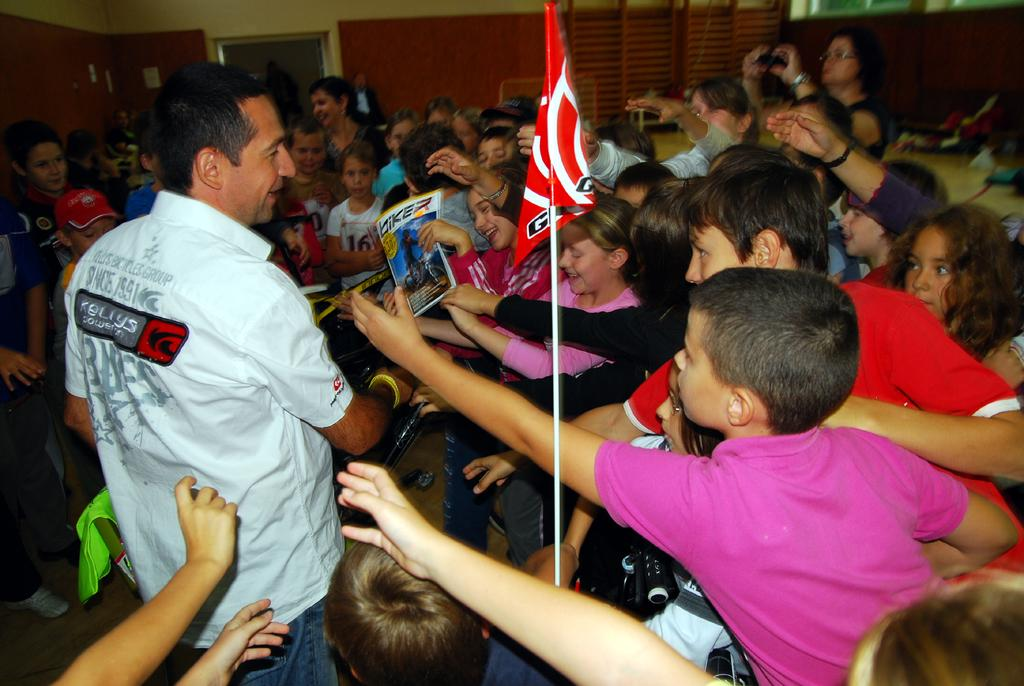What can be seen in the image in terms of people? There are people and children standing in the image. What is the prominent feature in the front of the image? There is a red color flag in the front of the image. How would you describe the quality of the image's background? The image is slightly blurry in the background. What type of linen is used to create the flag in the image? There is no information about the type of linen used to create the flag in the image. Who is the creator of the image? The creator of the image is not mentioned in the provided facts. 